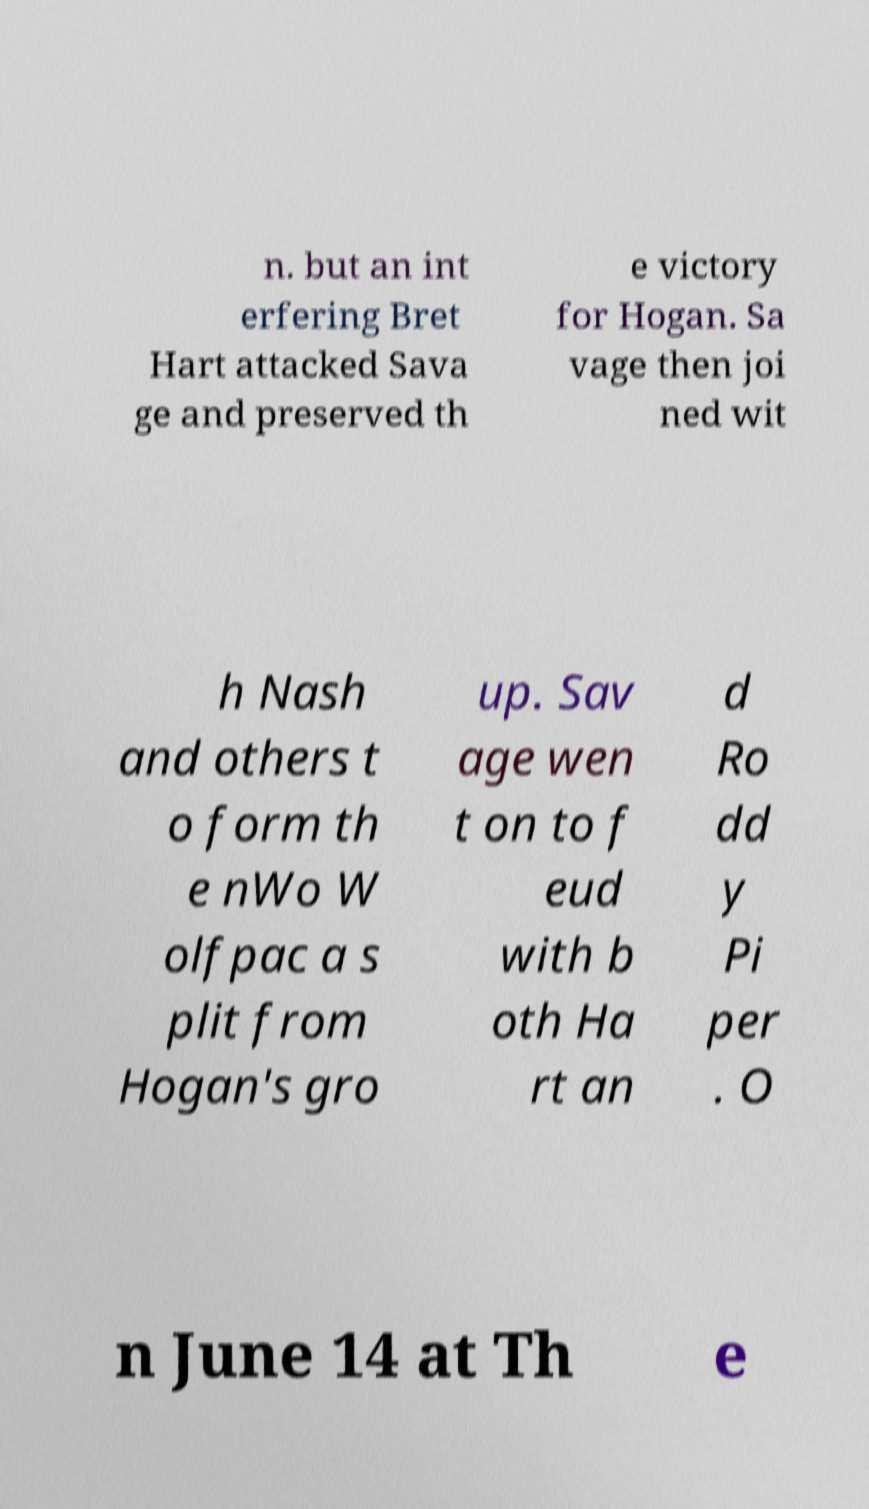Could you assist in decoding the text presented in this image and type it out clearly? n. but an int erfering Bret Hart attacked Sava ge and preserved th e victory for Hogan. Sa vage then joi ned wit h Nash and others t o form th e nWo W olfpac a s plit from Hogan's gro up. Sav age wen t on to f eud with b oth Ha rt an d Ro dd y Pi per . O n June 14 at Th e 